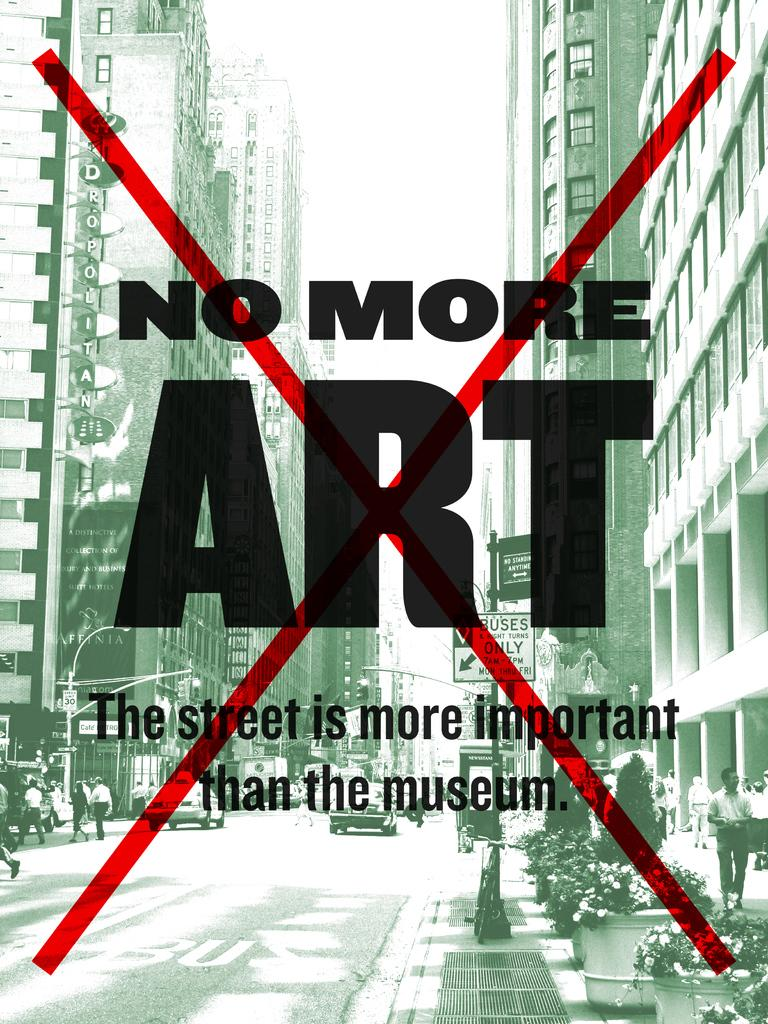<image>
Relay a brief, clear account of the picture shown. A poster with the words No More ART crossed out with a red X. 